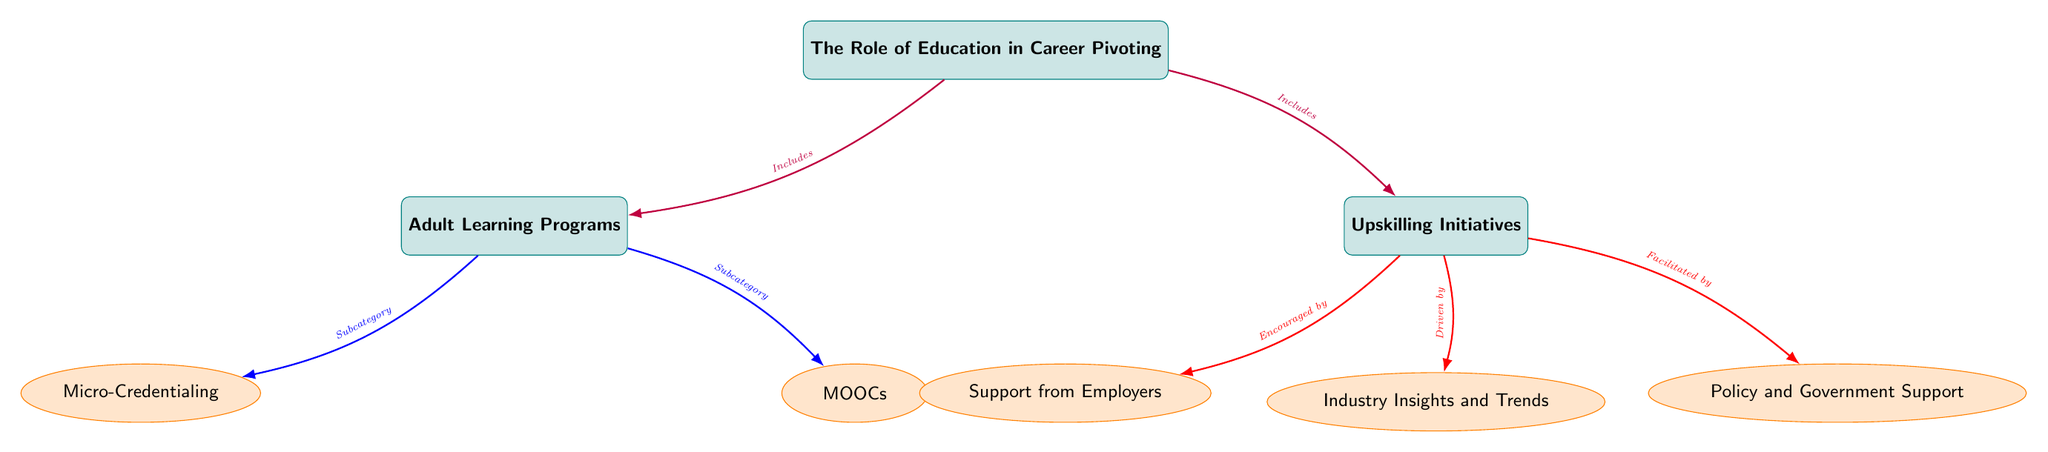What is the main focus of the diagram? The first node at the top of the diagram indicates that the primary focus is on "The Role of Education in Career Pivoting." This describes the general theme that connects all other nodes.
Answer: The Role of Education in Career Pivoting How many main nodes are present in the diagram? There are two main nodes below the central node: "Adult Learning Programs" and "Upskilling Initiatives." Counting the main nodes gives a total of two.
Answer: 2 What subcategory falls under Adult Learning Programs? The diagram shows two sub-nodes connected to "Adult Learning Programs," which are "Micro-Credentialing" and "MOOCs." Both are listed as subcategories, indicating educational formats.
Answer: Micro-Credentialing, MOOCs Which entities are part of Upskilling Initiatives? The "Upskilling Initiatives" node has three connections leading to its sub-nodes: "Industry Insights and Trends," "Support from Employers," and "Policy and Government Support." Therefore, these three represent the aspects contributing to upskilling.
Answer: Industry Insights and Trends, Support from Employers, Policy and Government Support Which aspect drives Upskilling Initiatives? The connection between "Upskilling Initiatives" and "Industry Insights and Trends" is marked with the phrase "Driven by." This indicates that the trends observed in various industries are significant motivators for upskilling programs.
Answer: Industry Insights and Trends What do Adult Learning Programs include? The relationships stemming from the main node "The Role of Education in Career Pivoting" both indicate that Adult Learning Programs are one of the core elements of this discussion. Thus, it is included among the main focus areas.
Answer: Adult Learning Programs How are Upskilling Initiatives encouraged? The diagram indicates that the node "Support from Employers" is connected to "Upskilling Initiatives" and labeled "Encouraged by." This shows that employer support plays a critical role in promoting upskilling efforts.
Answer: Support from Employers What is a subcategory of Adult Learning Programs that can be pursued online? "MOOCs," positioned as a sub-node of "Adult Learning Programs," is identified as an educational format available online, making it noteworthy in adult education.
Answer: MOOCs Which type of support is identified to facilitate Upskilling Initiatives? The connection to "Policy and Government Support" is labeled "Facilitated by," indicating that governmental policies and support mechanisms assist in the implementation of upskilling initiatives.
Answer: Policy and Government Support 